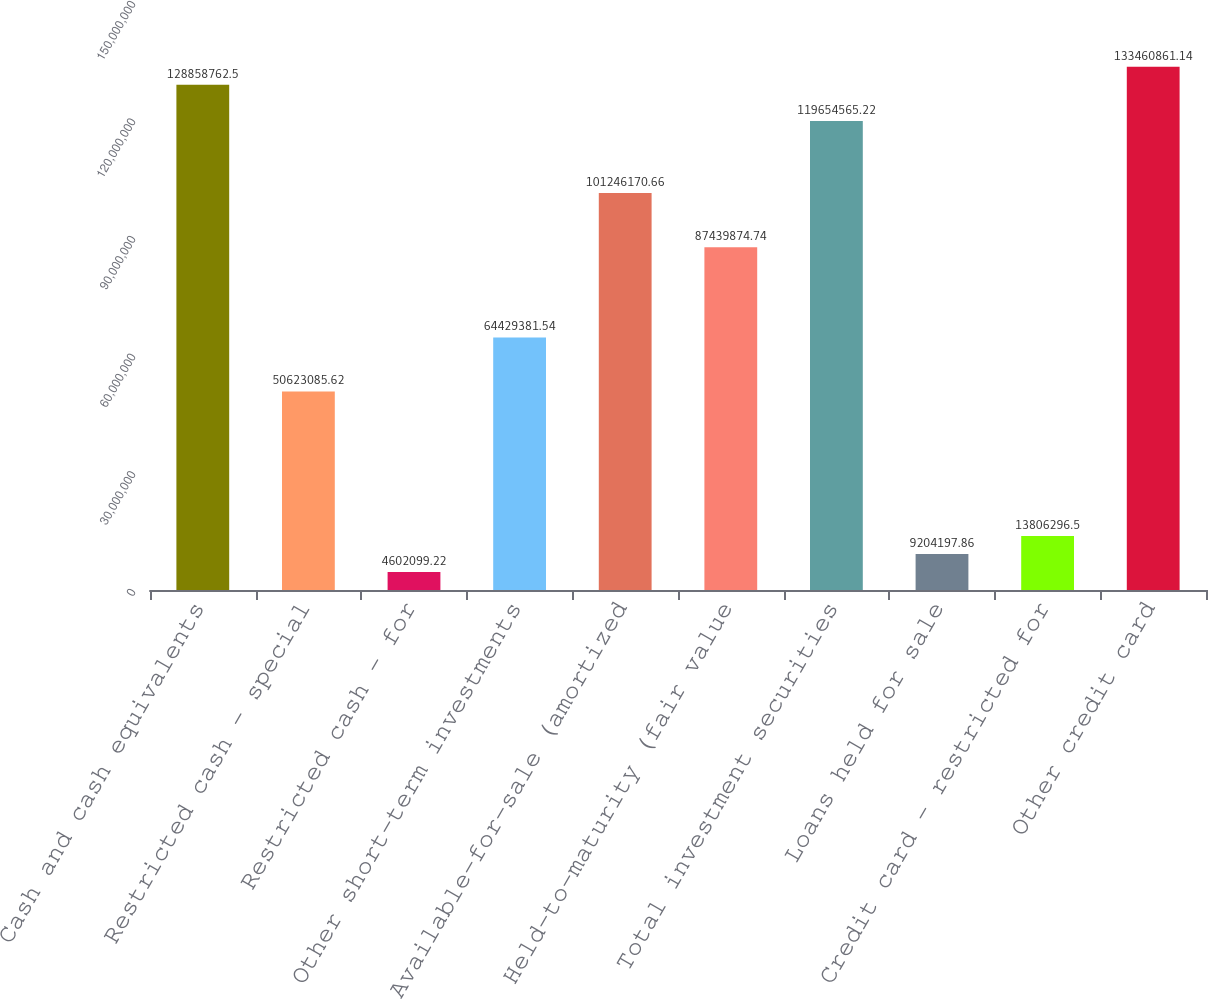Convert chart to OTSL. <chart><loc_0><loc_0><loc_500><loc_500><bar_chart><fcel>Cash and cash equivalents<fcel>Restricted cash - special<fcel>Restricted cash - for<fcel>Other short-term investments<fcel>Available-for-sale (amortized<fcel>Held-to-maturity (fair value<fcel>Total investment securities<fcel>Loans held for sale<fcel>Credit card - restricted for<fcel>Other credit card<nl><fcel>1.28859e+08<fcel>5.06231e+07<fcel>4.6021e+06<fcel>6.44294e+07<fcel>1.01246e+08<fcel>8.74399e+07<fcel>1.19655e+08<fcel>9.2042e+06<fcel>1.38063e+07<fcel>1.33461e+08<nl></chart> 